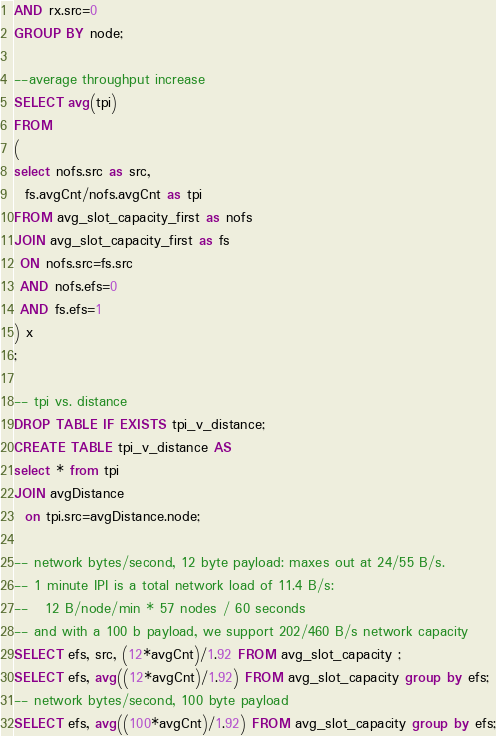<code> <loc_0><loc_0><loc_500><loc_500><_SQL_>AND rx.src=0
GROUP BY node;

--average throughput increase
SELECT avg(tpi)
FROM 
(
select nofs.src as src, 
  fs.avgCnt/nofs.avgCnt as tpi
FROM avg_slot_capacity_first as nofs
JOIN avg_slot_capacity_first as fs
 ON nofs.src=fs.src
 AND nofs.efs=0
 AND fs.efs=1
) x
;

-- tpi vs. distance
DROP TABLE IF EXISTS tpi_v_distance;
CREATE TABLE tpi_v_distance AS
select * from tpi 
JOIN avgDistance 
  on tpi.src=avgDistance.node;

-- network bytes/second, 12 byte payload: maxes out at 24/55 B/s.
-- 1 minute IPI is a total network load of 11.4 B/s: 
--   12 B/node/min * 57 nodes / 60 seconds
-- and with a 100 b payload, we support 202/460 B/s network capacity
SELECT efs, src, (12*avgCnt)/1.92 FROM avg_slot_capacity ;
SELECT efs, avg((12*avgCnt)/1.92) FROM avg_slot_capacity group by efs;
-- network bytes/second, 100 byte payload
SELECT efs, avg((100*avgCnt)/1.92) FROM avg_slot_capacity group by efs;
</code> 